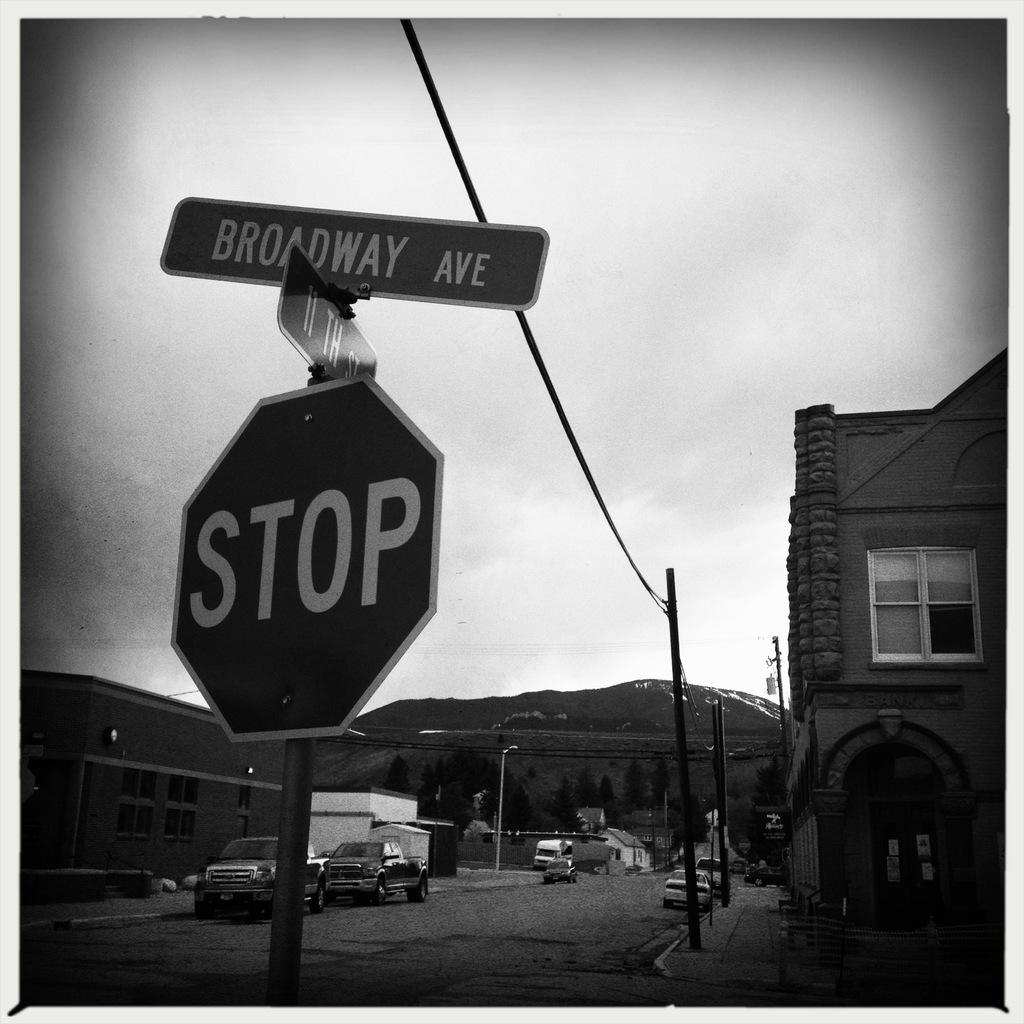<image>
Share a concise interpretation of the image provided. The street above the stop sign is named Broadway Ave 